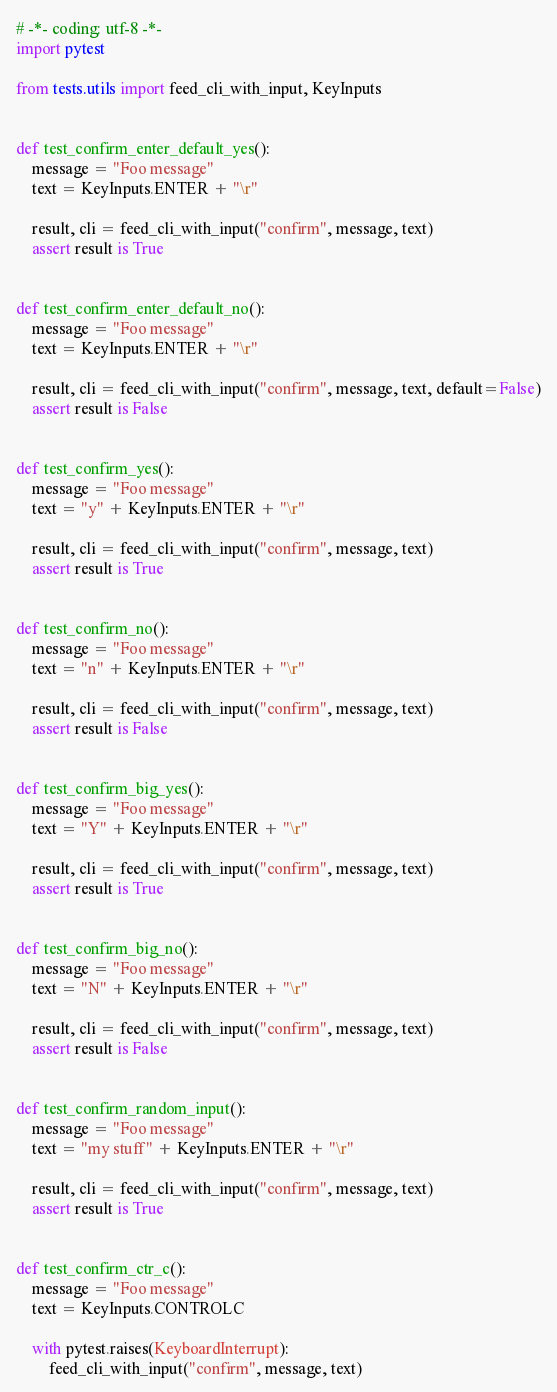Convert code to text. <code><loc_0><loc_0><loc_500><loc_500><_Python_># -*- coding: utf-8 -*-
import pytest

from tests.utils import feed_cli_with_input, KeyInputs


def test_confirm_enter_default_yes():
    message = "Foo message"
    text = KeyInputs.ENTER + "\r"

    result, cli = feed_cli_with_input("confirm", message, text)
    assert result is True


def test_confirm_enter_default_no():
    message = "Foo message"
    text = KeyInputs.ENTER + "\r"

    result, cli = feed_cli_with_input("confirm", message, text, default=False)
    assert result is False


def test_confirm_yes():
    message = "Foo message"
    text = "y" + KeyInputs.ENTER + "\r"

    result, cli = feed_cli_with_input("confirm", message, text)
    assert result is True


def test_confirm_no():
    message = "Foo message"
    text = "n" + KeyInputs.ENTER + "\r"

    result, cli = feed_cli_with_input("confirm", message, text)
    assert result is False


def test_confirm_big_yes():
    message = "Foo message"
    text = "Y" + KeyInputs.ENTER + "\r"

    result, cli = feed_cli_with_input("confirm", message, text)
    assert result is True


def test_confirm_big_no():
    message = "Foo message"
    text = "N" + KeyInputs.ENTER + "\r"

    result, cli = feed_cli_with_input("confirm", message, text)
    assert result is False


def test_confirm_random_input():
    message = "Foo message"
    text = "my stuff" + KeyInputs.ENTER + "\r"

    result, cli = feed_cli_with_input("confirm", message, text)
    assert result is True


def test_confirm_ctr_c():
    message = "Foo message"
    text = KeyInputs.CONTROLC

    with pytest.raises(KeyboardInterrupt):
        feed_cli_with_input("confirm", message, text)
</code> 